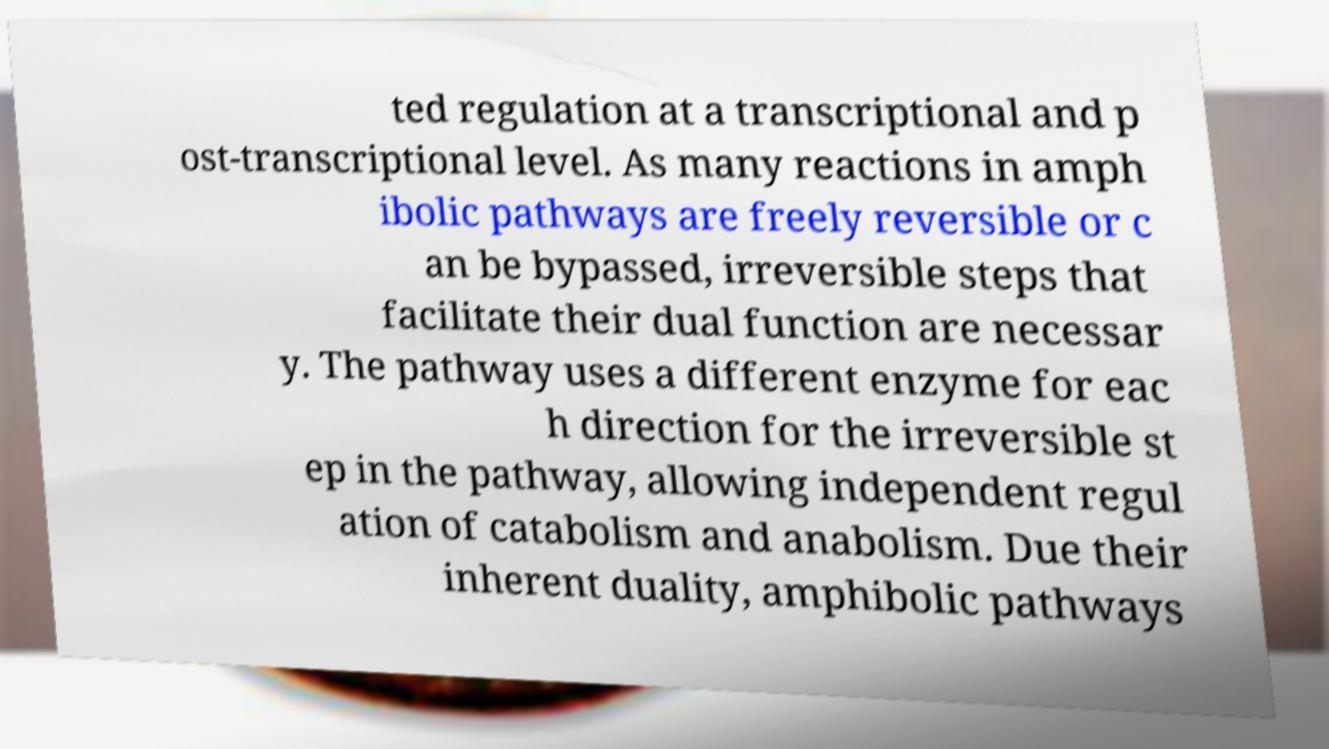Can you accurately transcribe the text from the provided image for me? ted regulation at a transcriptional and p ost-transcriptional level. As many reactions in amph ibolic pathways are freely reversible or c an be bypassed, irreversible steps that facilitate their dual function are necessar y. The pathway uses a different enzyme for eac h direction for the irreversible st ep in the pathway, allowing independent regul ation of catabolism and anabolism. Due their inherent duality, amphibolic pathways 